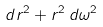<formula> <loc_0><loc_0><loc_500><loc_500>d r ^ { 2 } + r ^ { 2 } \, d \omega ^ { 2 }</formula> 